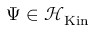Convert formula to latex. <formula><loc_0><loc_0><loc_500><loc_500>\Psi \in { \mathcal { H } } _ { K i n }</formula> 